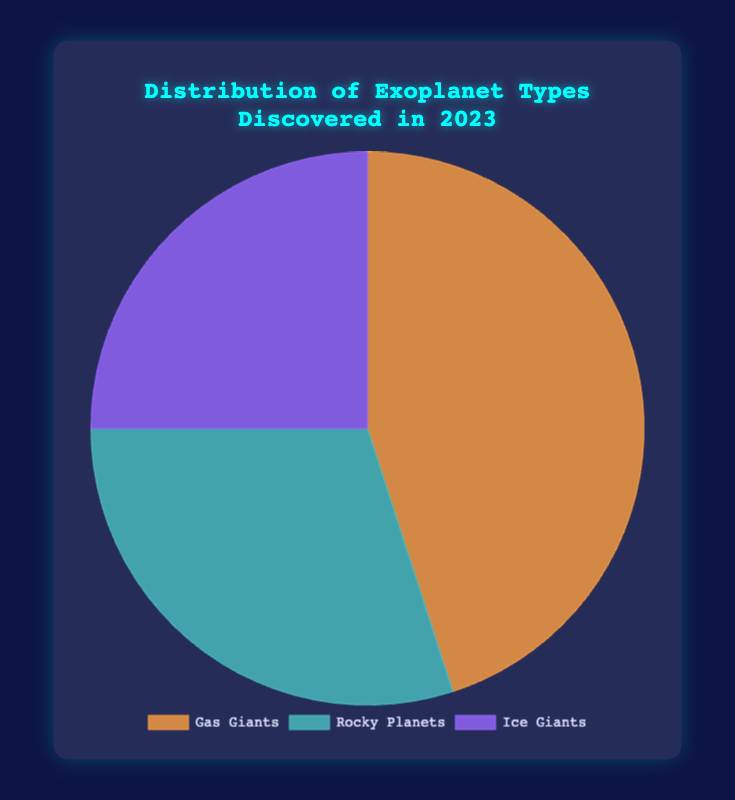What percentage of the exoplanets discovered in 2023 are Gas Giants? Referring to the figure, Gas Giants account for 45% of the total exoplanets discovered in 2023. The pie chart segment for Gas Giants covers 45% of the circle.
Answer: 45% Which type of exoplanet is the most prevalent among discoveries in 2023? Observing the pie chart, the largest segment corresponds to Gas Giants, which indicates that Gas Giants are the most prevalent among the exoplanet discoveries in 2023 with a 45% share.
Answer: Gas Giants What is the combined percentage of Rocky Planets and Ice Giants discovered in 2023? Adding the percentages of Rocky Planets (30%) and Ice Giants (25%) discovered in 2023 results in a combined percentage of 30% + 25% = 55%.
Answer: 55% Are Rocky Planets more or less common than Ice Giants based on discoveries in 2023? By looking at the pie chart, the segment for Rocky Planets is larger than the segment for Ice Giants, indicating that Rocky Planets (30%) are more common than Ice Giants (25%).
Answer: More common What is the difference in percentage between the most and least common types of exoplanets discovered in 2023? The most common type of exoplanet discovered in 2023 is Gas Giants at 45%, and the least common is Ice Giants at 25%. The difference in percentage is 45% - 25% = 20%.
Answer: 20% If you were to group Gas Giants and Ice Giants together, what percentage of the total discoveries would they represent? Adding the percentages of Gas Giants (45%) and Ice Giants (25%) gives a combined representation of 45% + 25% = 70%.
Answer: 70% Does any exoplanet type account for exactly half of the total discoveries in 2023? Examining the percentages shown in the pie chart (45% for Gas Giants, 30% for Rocky Planets, and 25% for Ice Giants), none of these percentages equal exactly 50%.
Answer: No Which type of exoplanet has the smallest segment in the pie chart, and what is its percentage? The smalles segment in the pie chart corresponds to Ice Giants, which are represented by a percentage of 25%.
Answer: Ice Giants, 25% What is the average percentage of the three types of exoplanets discovered in 2023? To find the average percentage, add up the individual percentages: 45% (Gas Giants) + 30% (Rocky Planets) + 25% (Ice Giants) = 100%. Then, divide by the number of types, which is 3. The average is 100% / 3 ≈ 33.33%.
Answer: 33.33% 